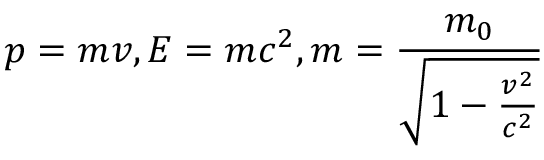<formula> <loc_0><loc_0><loc_500><loc_500>p = m v , E = m c ^ { 2 } , m = \frac { m _ { 0 } } { \sqrt { 1 - \frac { v ^ { 2 } } { c ^ { 2 } } } }</formula> 